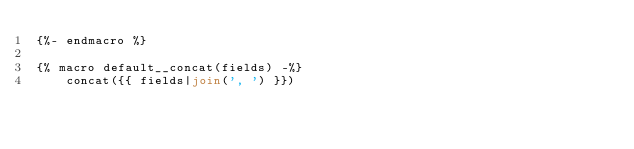Convert code to text. <code><loc_0><loc_0><loc_500><loc_500><_SQL_>{%- endmacro %}

{% macro default__concat(fields) -%}
    concat({{ fields|join(', ') }})</code> 